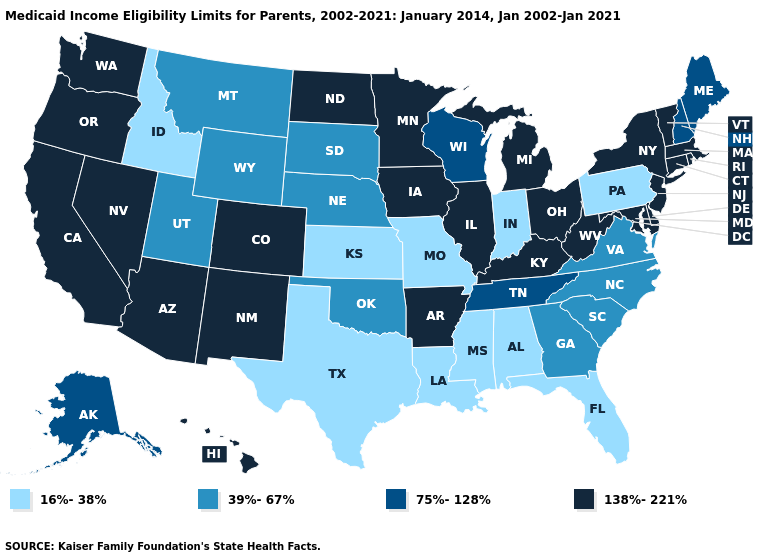What is the value of New Mexico?
Concise answer only. 138%-221%. Name the states that have a value in the range 16%-38%?
Concise answer only. Alabama, Florida, Idaho, Indiana, Kansas, Louisiana, Mississippi, Missouri, Pennsylvania, Texas. What is the highest value in states that border Oklahoma?
Write a very short answer. 138%-221%. Among the states that border Maryland , which have the highest value?
Quick response, please. Delaware, West Virginia. What is the highest value in the MidWest ?
Short answer required. 138%-221%. Name the states that have a value in the range 75%-128%?
Short answer required. Alaska, Maine, New Hampshire, Tennessee, Wisconsin. Name the states that have a value in the range 138%-221%?
Be succinct. Arizona, Arkansas, California, Colorado, Connecticut, Delaware, Hawaii, Illinois, Iowa, Kentucky, Maryland, Massachusetts, Michigan, Minnesota, Nevada, New Jersey, New Mexico, New York, North Dakota, Ohio, Oregon, Rhode Island, Vermont, Washington, West Virginia. Does Texas have the same value as Arizona?
Answer briefly. No. Among the states that border Kansas , which have the highest value?
Give a very brief answer. Colorado. What is the highest value in the USA?
Quick response, please. 138%-221%. Among the states that border New Jersey , which have the lowest value?
Short answer required. Pennsylvania. What is the value of Michigan?
Be succinct. 138%-221%. Does Nevada have the lowest value in the USA?
Give a very brief answer. No. What is the value of South Carolina?
Be succinct. 39%-67%. What is the lowest value in the USA?
Give a very brief answer. 16%-38%. 